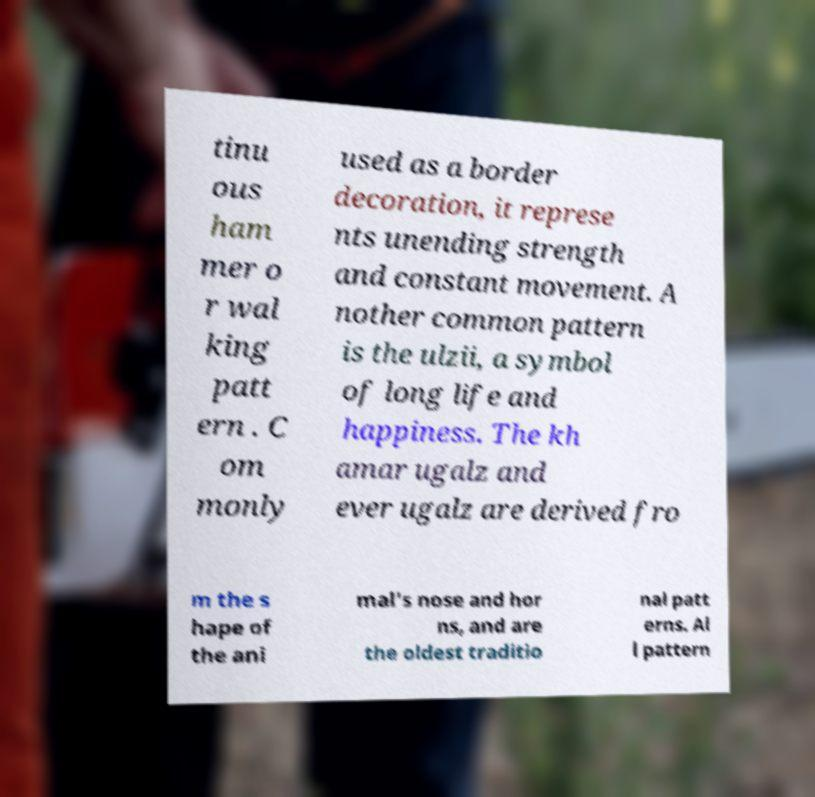Can you accurately transcribe the text from the provided image for me? tinu ous ham mer o r wal king patt ern . C om monly used as a border decoration, it represe nts unending strength and constant movement. A nother common pattern is the ulzii, a symbol of long life and happiness. The kh amar ugalz and ever ugalz are derived fro m the s hape of the ani mal's nose and hor ns, and are the oldest traditio nal patt erns. Al l pattern 